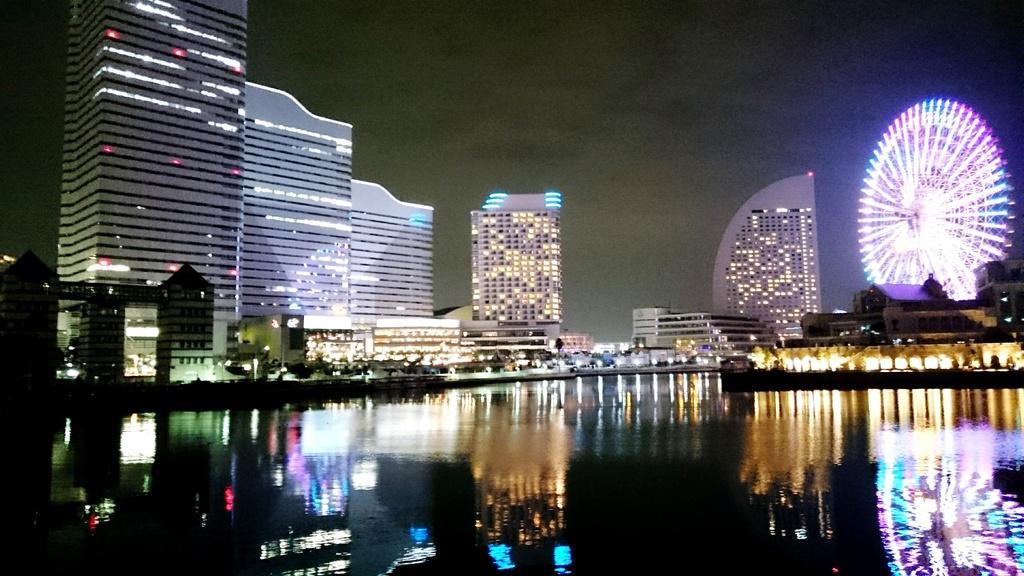Could you give a brief overview of what you see in this image? At the bottom of this image, there is water. In the background, there are buildings which are having lights, there is a giant wheel, which is having lighting, there are lights arranged and there are clouds in the sky. 